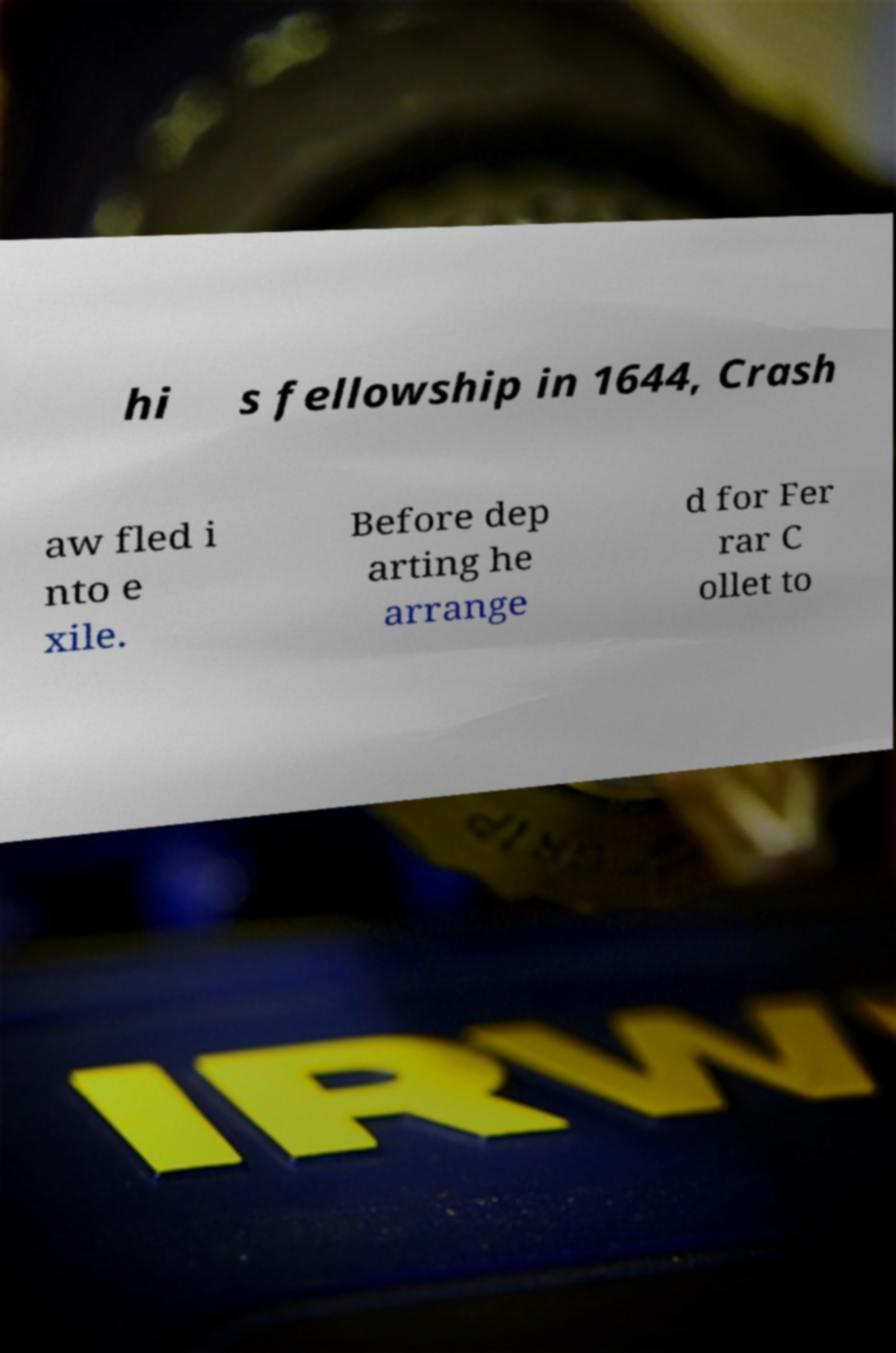Could you extract and type out the text from this image? hi s fellowship in 1644, Crash aw fled i nto e xile. Before dep arting he arrange d for Fer rar C ollet to 